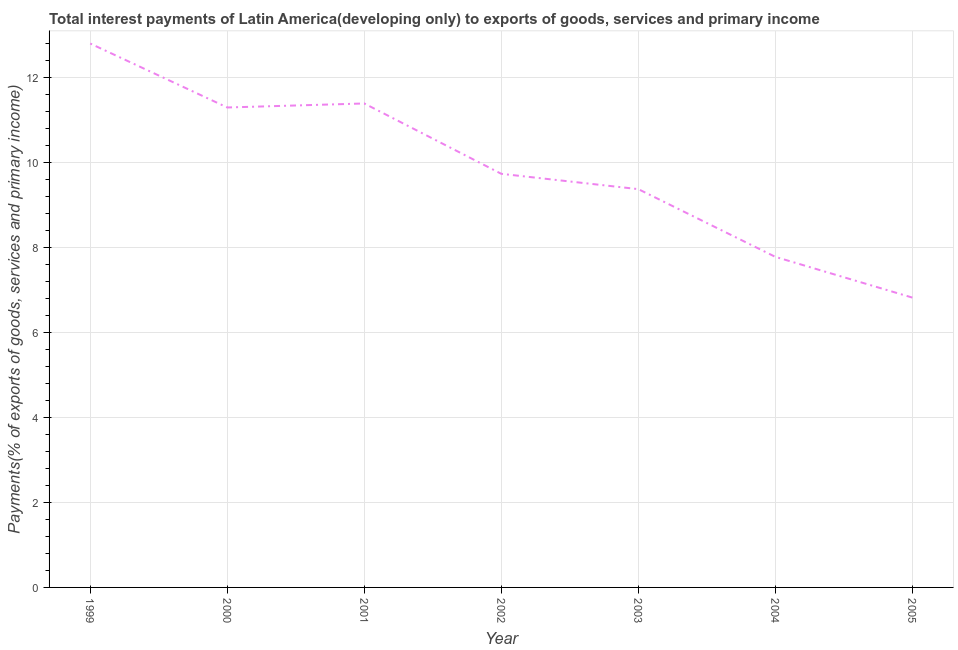What is the total interest payments on external debt in 2005?
Give a very brief answer. 6.82. Across all years, what is the maximum total interest payments on external debt?
Provide a short and direct response. 12.8. Across all years, what is the minimum total interest payments on external debt?
Offer a terse response. 6.82. What is the sum of the total interest payments on external debt?
Provide a short and direct response. 69.17. What is the difference between the total interest payments on external debt in 1999 and 2004?
Make the answer very short. 5.02. What is the average total interest payments on external debt per year?
Your answer should be compact. 9.88. What is the median total interest payments on external debt?
Your answer should be compact. 9.73. Do a majority of the years between 1999 and 2000 (inclusive) have total interest payments on external debt greater than 6.8 %?
Provide a short and direct response. Yes. What is the ratio of the total interest payments on external debt in 2002 to that in 2004?
Your answer should be compact. 1.25. Is the total interest payments on external debt in 2000 less than that in 2004?
Your answer should be very brief. No. Is the difference between the total interest payments on external debt in 2002 and 2005 greater than the difference between any two years?
Make the answer very short. No. What is the difference between the highest and the second highest total interest payments on external debt?
Offer a terse response. 1.41. Is the sum of the total interest payments on external debt in 2000 and 2005 greater than the maximum total interest payments on external debt across all years?
Your response must be concise. Yes. What is the difference between the highest and the lowest total interest payments on external debt?
Your response must be concise. 5.98. Does the total interest payments on external debt monotonically increase over the years?
Your response must be concise. No. How many lines are there?
Provide a short and direct response. 1. How many years are there in the graph?
Offer a very short reply. 7. Does the graph contain grids?
Keep it short and to the point. Yes. What is the title of the graph?
Give a very brief answer. Total interest payments of Latin America(developing only) to exports of goods, services and primary income. What is the label or title of the Y-axis?
Make the answer very short. Payments(% of exports of goods, services and primary income). What is the Payments(% of exports of goods, services and primary income) in 1999?
Your answer should be compact. 12.8. What is the Payments(% of exports of goods, services and primary income) in 2000?
Your answer should be compact. 11.29. What is the Payments(% of exports of goods, services and primary income) of 2001?
Give a very brief answer. 11.39. What is the Payments(% of exports of goods, services and primary income) of 2002?
Offer a terse response. 9.73. What is the Payments(% of exports of goods, services and primary income) in 2003?
Give a very brief answer. 9.37. What is the Payments(% of exports of goods, services and primary income) in 2004?
Offer a very short reply. 7.78. What is the Payments(% of exports of goods, services and primary income) in 2005?
Offer a very short reply. 6.82. What is the difference between the Payments(% of exports of goods, services and primary income) in 1999 and 2000?
Ensure brevity in your answer.  1.5. What is the difference between the Payments(% of exports of goods, services and primary income) in 1999 and 2001?
Your answer should be very brief. 1.41. What is the difference between the Payments(% of exports of goods, services and primary income) in 1999 and 2002?
Provide a short and direct response. 3.07. What is the difference between the Payments(% of exports of goods, services and primary income) in 1999 and 2003?
Your answer should be very brief. 3.43. What is the difference between the Payments(% of exports of goods, services and primary income) in 1999 and 2004?
Your answer should be very brief. 5.02. What is the difference between the Payments(% of exports of goods, services and primary income) in 1999 and 2005?
Make the answer very short. 5.98. What is the difference between the Payments(% of exports of goods, services and primary income) in 2000 and 2001?
Offer a terse response. -0.09. What is the difference between the Payments(% of exports of goods, services and primary income) in 2000 and 2002?
Provide a succinct answer. 1.56. What is the difference between the Payments(% of exports of goods, services and primary income) in 2000 and 2003?
Provide a short and direct response. 1.92. What is the difference between the Payments(% of exports of goods, services and primary income) in 2000 and 2004?
Give a very brief answer. 3.51. What is the difference between the Payments(% of exports of goods, services and primary income) in 2000 and 2005?
Make the answer very short. 4.47. What is the difference between the Payments(% of exports of goods, services and primary income) in 2001 and 2002?
Provide a succinct answer. 1.66. What is the difference between the Payments(% of exports of goods, services and primary income) in 2001 and 2003?
Your answer should be compact. 2.02. What is the difference between the Payments(% of exports of goods, services and primary income) in 2001 and 2004?
Provide a short and direct response. 3.61. What is the difference between the Payments(% of exports of goods, services and primary income) in 2001 and 2005?
Your response must be concise. 4.57. What is the difference between the Payments(% of exports of goods, services and primary income) in 2002 and 2003?
Give a very brief answer. 0.36. What is the difference between the Payments(% of exports of goods, services and primary income) in 2002 and 2004?
Your answer should be compact. 1.95. What is the difference between the Payments(% of exports of goods, services and primary income) in 2002 and 2005?
Your answer should be very brief. 2.91. What is the difference between the Payments(% of exports of goods, services and primary income) in 2003 and 2004?
Give a very brief answer. 1.59. What is the difference between the Payments(% of exports of goods, services and primary income) in 2003 and 2005?
Your answer should be compact. 2.55. What is the difference between the Payments(% of exports of goods, services and primary income) in 2004 and 2005?
Keep it short and to the point. 0.96. What is the ratio of the Payments(% of exports of goods, services and primary income) in 1999 to that in 2000?
Offer a very short reply. 1.13. What is the ratio of the Payments(% of exports of goods, services and primary income) in 1999 to that in 2001?
Give a very brief answer. 1.12. What is the ratio of the Payments(% of exports of goods, services and primary income) in 1999 to that in 2002?
Your answer should be compact. 1.31. What is the ratio of the Payments(% of exports of goods, services and primary income) in 1999 to that in 2003?
Give a very brief answer. 1.37. What is the ratio of the Payments(% of exports of goods, services and primary income) in 1999 to that in 2004?
Make the answer very short. 1.65. What is the ratio of the Payments(% of exports of goods, services and primary income) in 1999 to that in 2005?
Your answer should be compact. 1.88. What is the ratio of the Payments(% of exports of goods, services and primary income) in 2000 to that in 2002?
Provide a succinct answer. 1.16. What is the ratio of the Payments(% of exports of goods, services and primary income) in 2000 to that in 2003?
Your answer should be very brief. 1.21. What is the ratio of the Payments(% of exports of goods, services and primary income) in 2000 to that in 2004?
Your answer should be compact. 1.45. What is the ratio of the Payments(% of exports of goods, services and primary income) in 2000 to that in 2005?
Provide a succinct answer. 1.66. What is the ratio of the Payments(% of exports of goods, services and primary income) in 2001 to that in 2002?
Provide a succinct answer. 1.17. What is the ratio of the Payments(% of exports of goods, services and primary income) in 2001 to that in 2003?
Offer a very short reply. 1.22. What is the ratio of the Payments(% of exports of goods, services and primary income) in 2001 to that in 2004?
Your response must be concise. 1.46. What is the ratio of the Payments(% of exports of goods, services and primary income) in 2001 to that in 2005?
Provide a short and direct response. 1.67. What is the ratio of the Payments(% of exports of goods, services and primary income) in 2002 to that in 2003?
Your response must be concise. 1.04. What is the ratio of the Payments(% of exports of goods, services and primary income) in 2002 to that in 2004?
Your answer should be very brief. 1.25. What is the ratio of the Payments(% of exports of goods, services and primary income) in 2002 to that in 2005?
Provide a short and direct response. 1.43. What is the ratio of the Payments(% of exports of goods, services and primary income) in 2003 to that in 2004?
Provide a short and direct response. 1.21. What is the ratio of the Payments(% of exports of goods, services and primary income) in 2003 to that in 2005?
Ensure brevity in your answer.  1.37. What is the ratio of the Payments(% of exports of goods, services and primary income) in 2004 to that in 2005?
Provide a short and direct response. 1.14. 